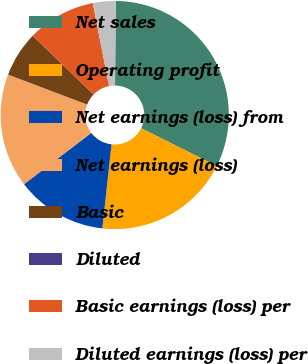<chart> <loc_0><loc_0><loc_500><loc_500><pie_chart><fcel>Net sales<fcel>Operating profit<fcel>Net earnings (loss) from<fcel>Net earnings (loss)<fcel>Basic<fcel>Diluted<fcel>Basic earnings (loss) per<fcel>Diluted earnings (loss) per<nl><fcel>32.24%<fcel>19.35%<fcel>12.9%<fcel>16.13%<fcel>6.46%<fcel>0.01%<fcel>9.68%<fcel>3.23%<nl></chart> 